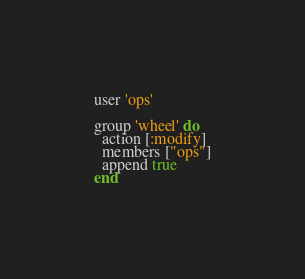Convert code to text. <code><loc_0><loc_0><loc_500><loc_500><_Ruby_>user 'ops'

group 'wheel' do
  action [:modify]
  members ["ops"]
  append true
end
</code> 